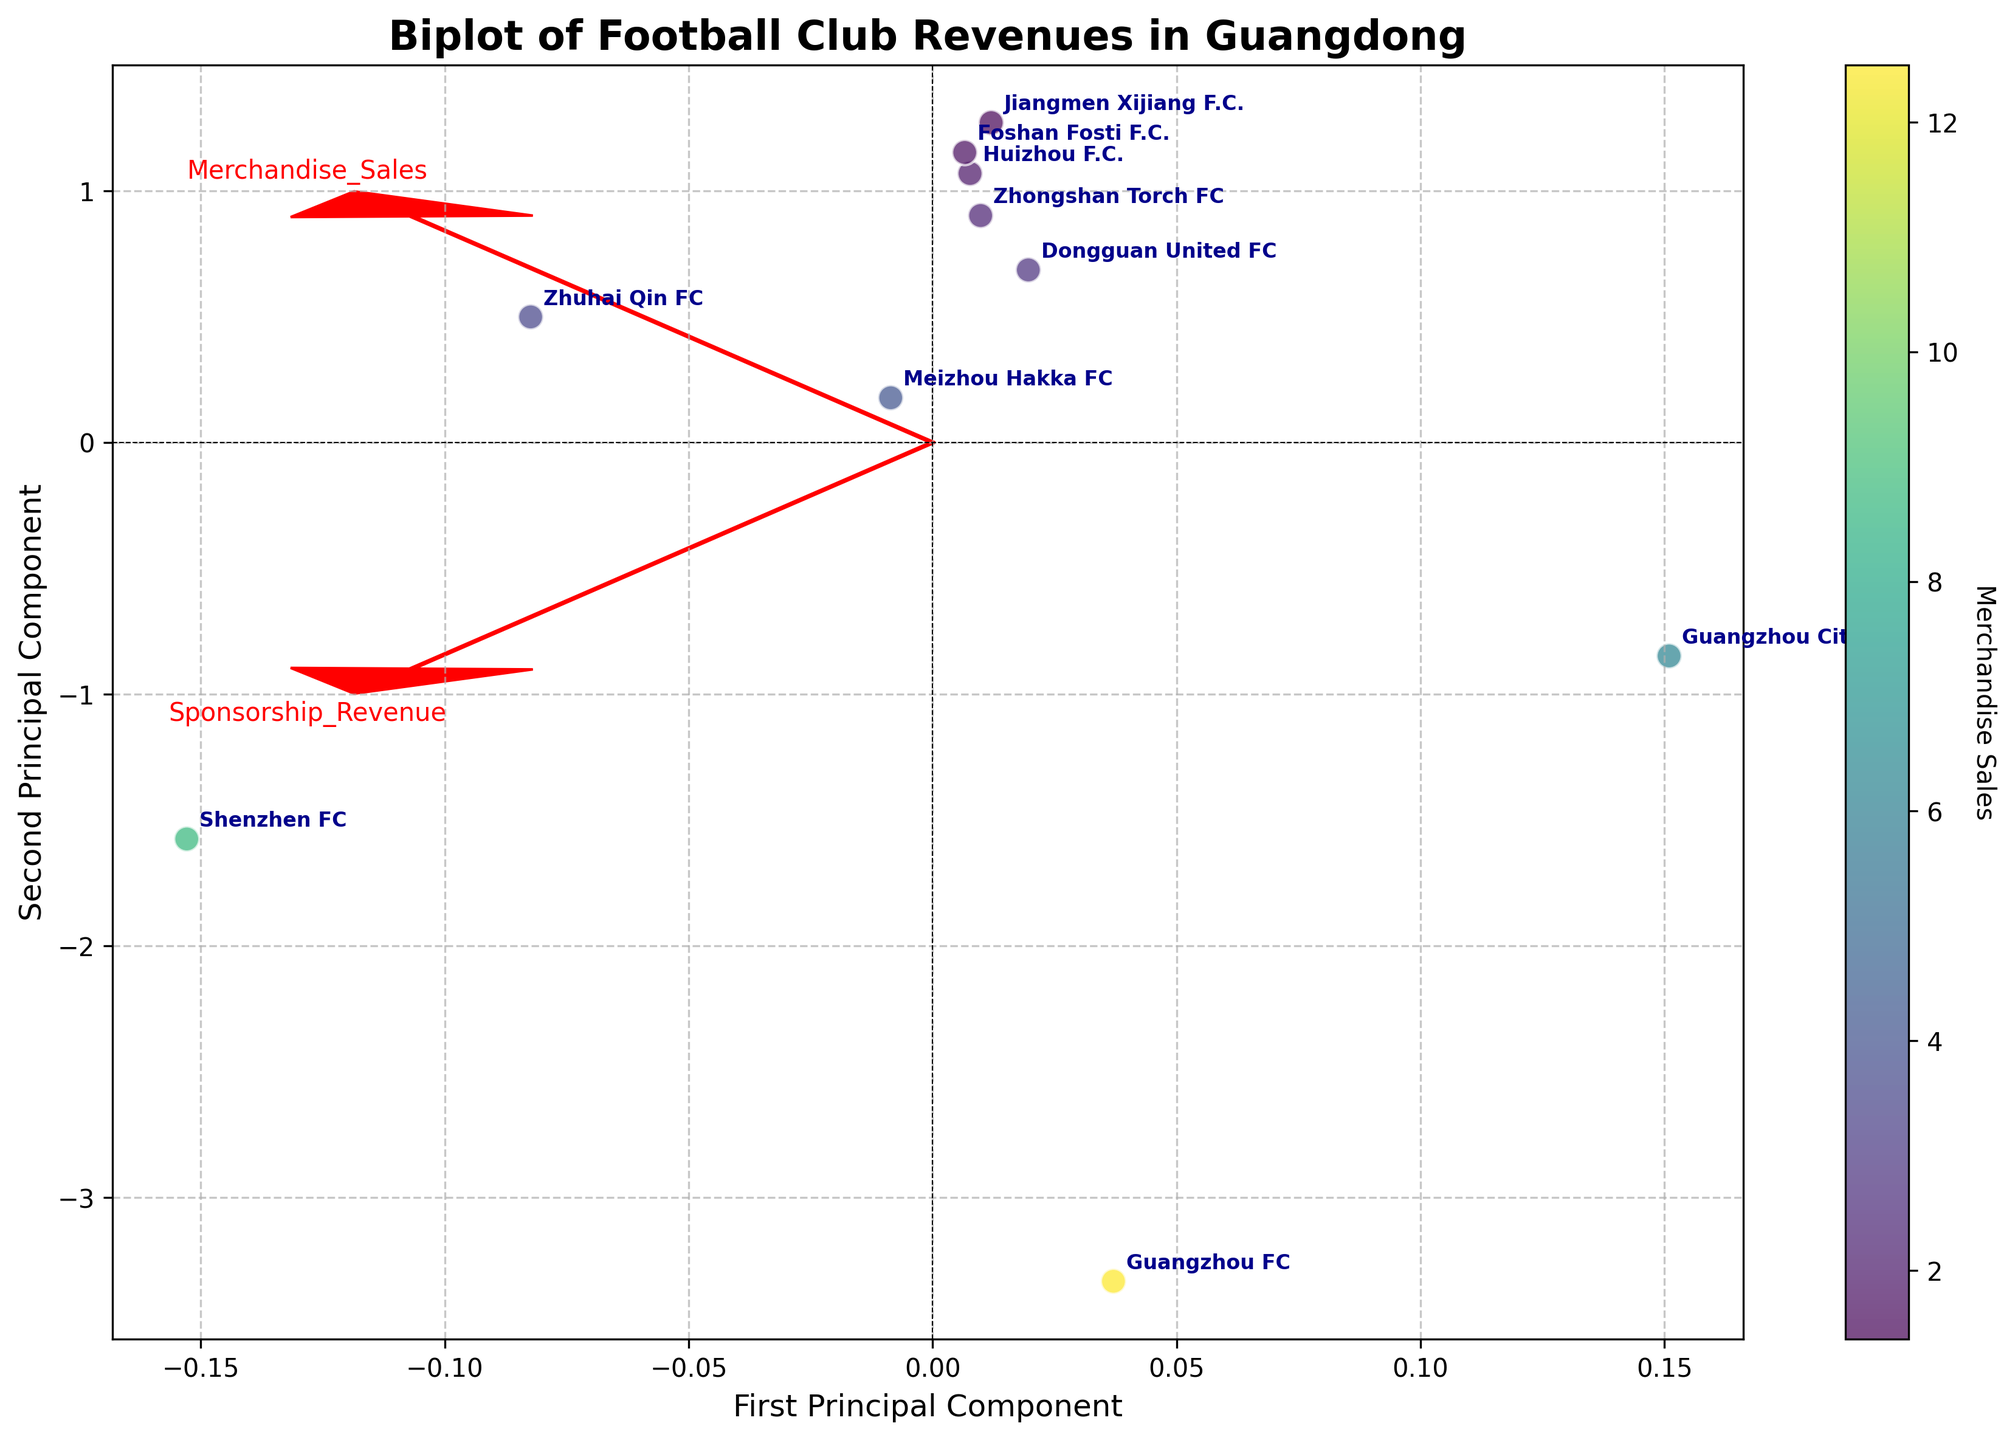What is the title of the figure? The title is located at the top of the figure, it reads "Biplot of Football Club Revenues in Guangdong".
Answer: Biplot of Football Club Revenues in Guangdong How many clubs are represented in the biplot? Each club is represented by a data point and annotated with the club's name. There are 10 clubs mentioned.
Answer: 10 Which club has the highest Merchandise Sales? The colorbar indicates that the data points with the lightest color represent higher Merchandise Sales. The club with the lightest color is Guangzhou FC, indicating it has the highest Merchandise Sales.
Answer: Guangzhou FC Which club has the lowest Sponsorship Revenue? The position along the y-axis primarily represents Sponsorship Revenue, with lower positions indicating lower values. The club positioned lowest on the y-axis is Jiangmen Xijiang F.C.
Answer: Jiangmen Xijiang F.C What do the arrows in the plot represent? The arrows are feature vectors for Merchandise Sales and Sponsorship Revenue. They indicate the direction and importance of these features in the principal component space.
Answer: Feature vectors for Merchandise Sales and Sponsorship Revenue How are Guangzhou FC and Shenzhen FC visually depicted in the biplot? Guangzhou FC is positioned at the top right and is colored the lightest, indicating high Merchandise Sales and Sponsorship Revenue. Shenzhen FC is near it but slightly lower and less bright, indicating slightly lower values for both features.
Answer: Top right for both, Guangzhou FC lighter than Shenzhen FC Are there any clubs with approximately equal Merchandise Sales and Sponsorship Revenue? Clubs with points near the 45-degree line from the origin likely have equal values for both features. Zhuhai Qin FC is close to such a line, suggesting its Merchandise Sales and Sponsorship Revenue are approximately equal.
Answer: Zhuhai Qin FC Which principal component axis shows more variation in the data? By observing the spread of the data points along the two principal component axes, we can infer that the first principal component axis (horizontal) has a greater spread, indicating more variance in that component.
Answer: First Principal Component How much of the total variance do the two principal components capture together? This requires knowing the explained variance by each component, which can typically be estimated from the spread of the data points and the length of the feature vectors. The first principal component usually captures more variance than the second.
Answer: Unable to determine the exact value from the figure alone, but a rough estimate suggests significant variance captured by the first component Is there greater variance in Merchandise Sales or Sponsorship Revenue according to the biplot? By observing the length of the arrows (feature vectors), the Merchandise Sales arrow is longer, indicating a greater variance in Merchandise Sales compared to Sponsorship Revenue.
Answer: Merchandise Sales 